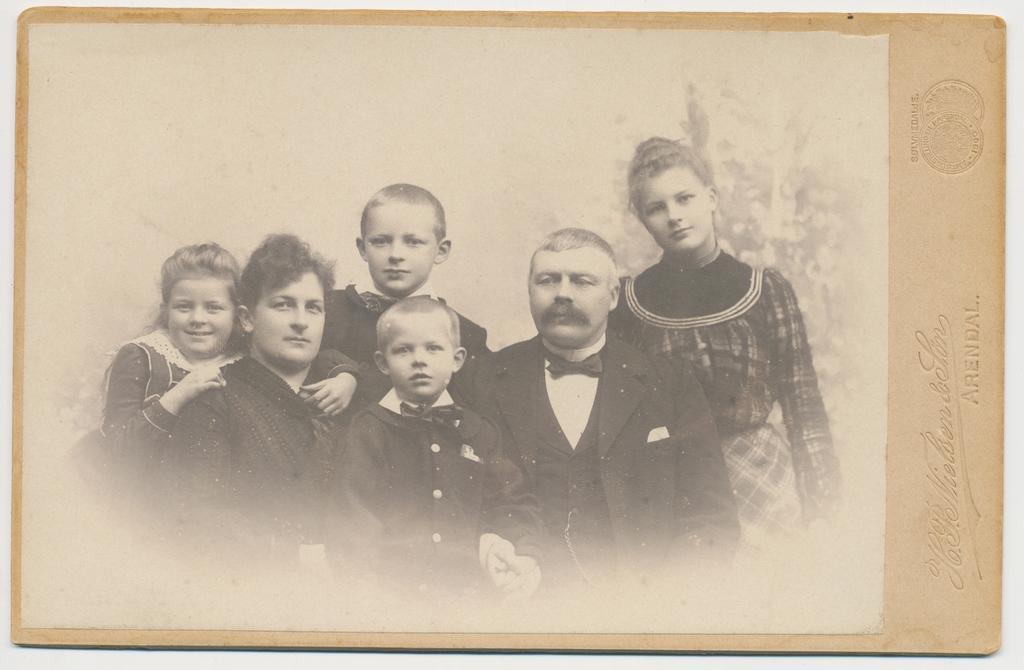How would you summarize this image in a sentence or two? In this image there is a photo frame on the wall. In the photograph there are people. There is some text and a watermark on the photo frame. 